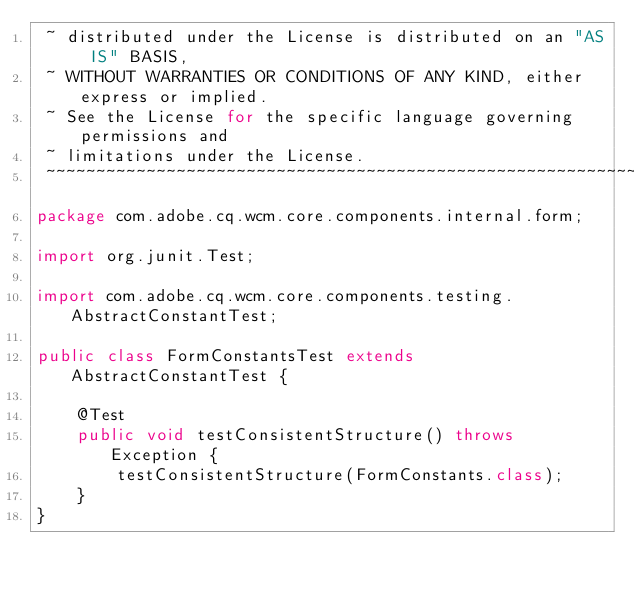Convert code to text. <code><loc_0><loc_0><loc_500><loc_500><_Java_> ~ distributed under the License is distributed on an "AS IS" BASIS,
 ~ WITHOUT WARRANTIES OR CONDITIONS OF ANY KIND, either express or implied.
 ~ See the License for the specific language governing permissions and
 ~ limitations under the License.
 ~~~~~~~~~~~~~~~~~~~~~~~~~~~~~~~~~~~~~~~~~~~~~~~~~~~~~~~~~~~~~~~~~~~~~~~~~~~~~*/
package com.adobe.cq.wcm.core.components.internal.form;

import org.junit.Test;

import com.adobe.cq.wcm.core.components.testing.AbstractConstantTest;

public class FormConstantsTest extends AbstractConstantTest {

    @Test
    public void testConsistentStructure() throws Exception {
        testConsistentStructure(FormConstants.class);
    }
}
</code> 